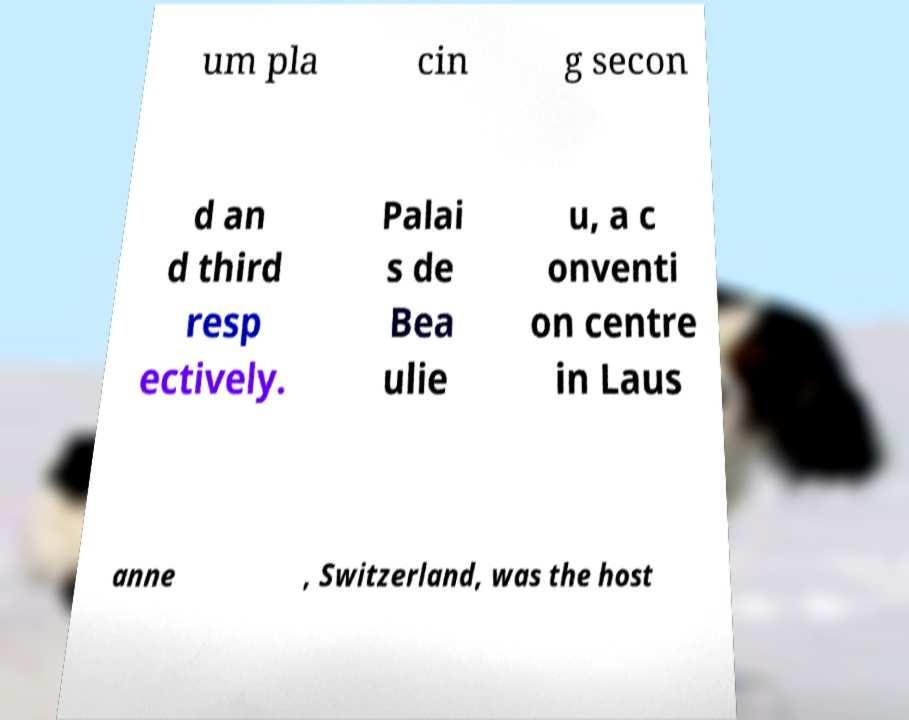Can you accurately transcribe the text from the provided image for me? um pla cin g secon d an d third resp ectively. Palai s de Bea ulie u, a c onventi on centre in Laus anne , Switzerland, was the host 